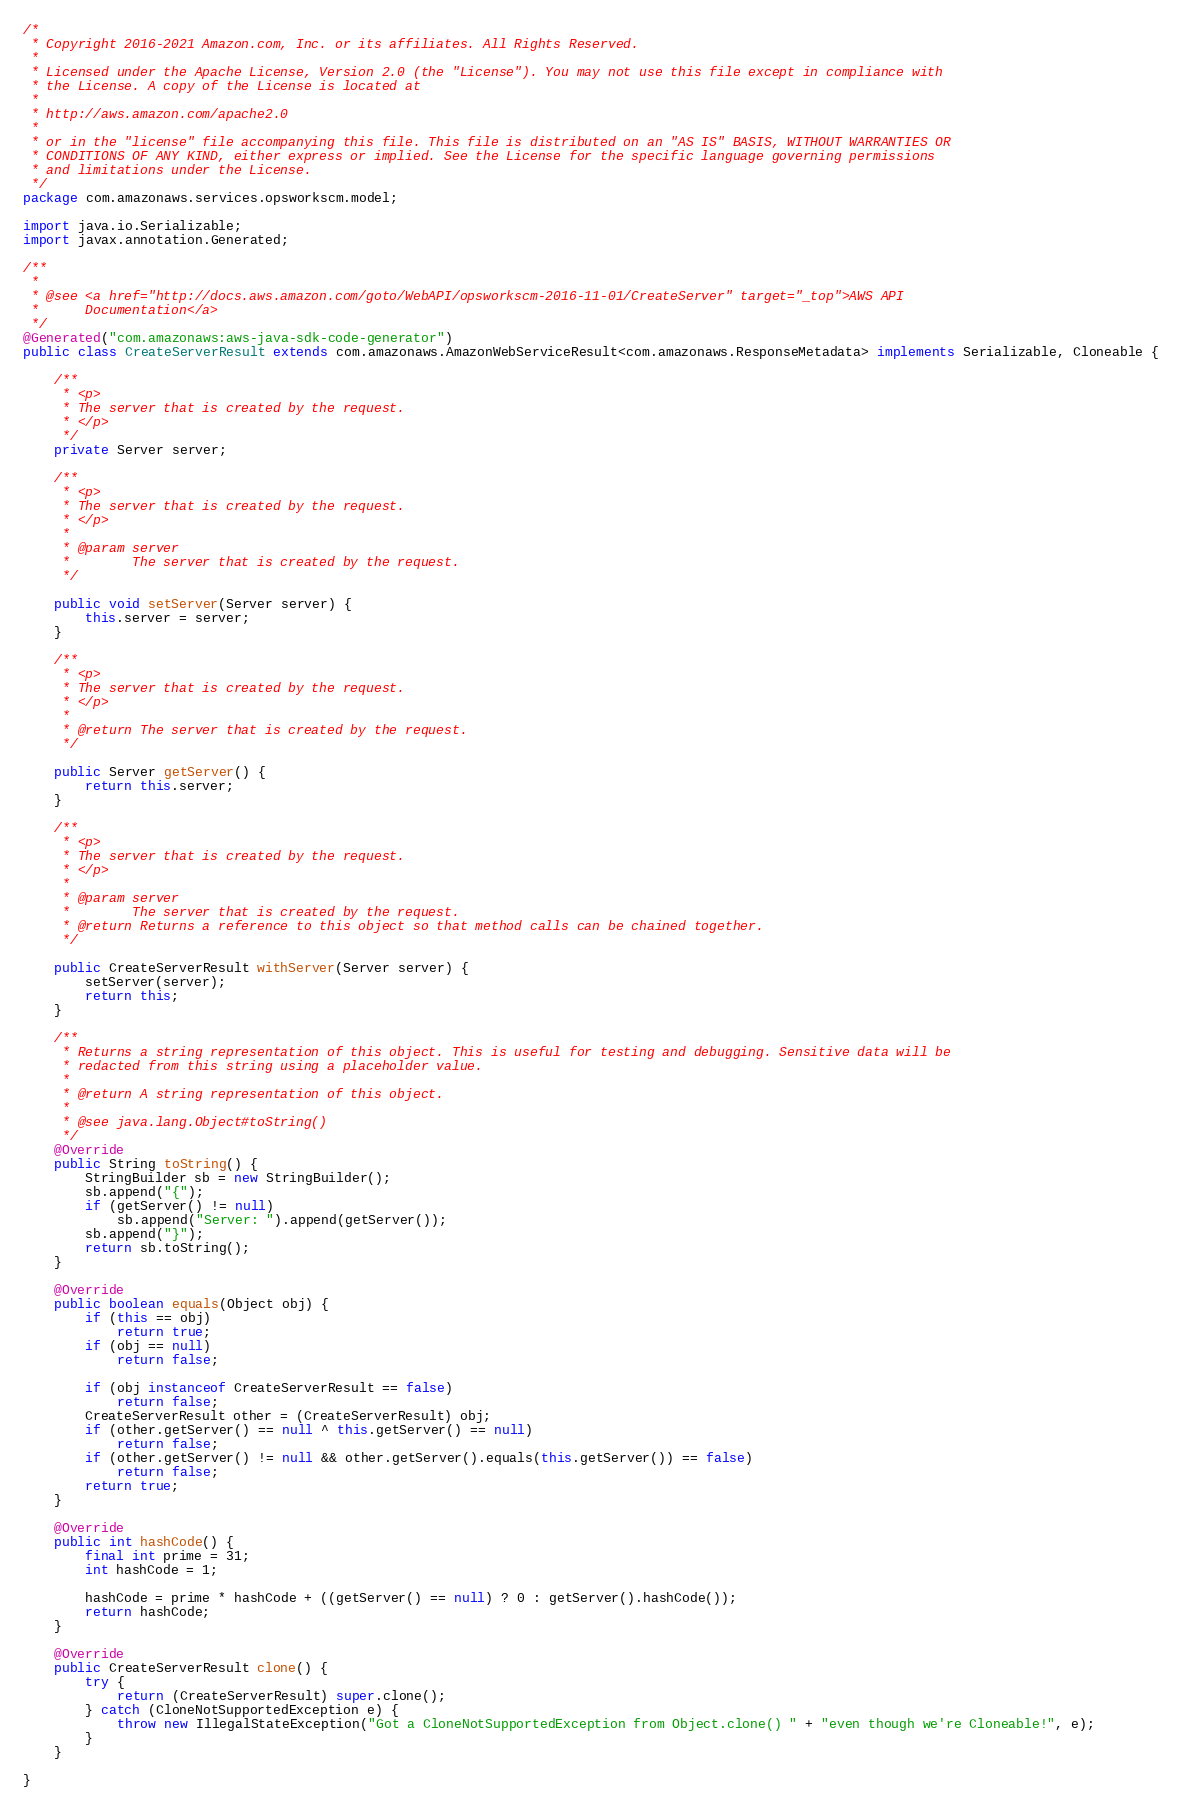<code> <loc_0><loc_0><loc_500><loc_500><_Java_>/*
 * Copyright 2016-2021 Amazon.com, Inc. or its affiliates. All Rights Reserved.
 * 
 * Licensed under the Apache License, Version 2.0 (the "License"). You may not use this file except in compliance with
 * the License. A copy of the License is located at
 * 
 * http://aws.amazon.com/apache2.0
 * 
 * or in the "license" file accompanying this file. This file is distributed on an "AS IS" BASIS, WITHOUT WARRANTIES OR
 * CONDITIONS OF ANY KIND, either express or implied. See the License for the specific language governing permissions
 * and limitations under the License.
 */
package com.amazonaws.services.opsworkscm.model;

import java.io.Serializable;
import javax.annotation.Generated;

/**
 * 
 * @see <a href="http://docs.aws.amazon.com/goto/WebAPI/opsworkscm-2016-11-01/CreateServer" target="_top">AWS API
 *      Documentation</a>
 */
@Generated("com.amazonaws:aws-java-sdk-code-generator")
public class CreateServerResult extends com.amazonaws.AmazonWebServiceResult<com.amazonaws.ResponseMetadata> implements Serializable, Cloneable {

    /**
     * <p>
     * The server that is created by the request.
     * </p>
     */
    private Server server;

    /**
     * <p>
     * The server that is created by the request.
     * </p>
     * 
     * @param server
     *        The server that is created by the request.
     */

    public void setServer(Server server) {
        this.server = server;
    }

    /**
     * <p>
     * The server that is created by the request.
     * </p>
     * 
     * @return The server that is created by the request.
     */

    public Server getServer() {
        return this.server;
    }

    /**
     * <p>
     * The server that is created by the request.
     * </p>
     * 
     * @param server
     *        The server that is created by the request.
     * @return Returns a reference to this object so that method calls can be chained together.
     */

    public CreateServerResult withServer(Server server) {
        setServer(server);
        return this;
    }

    /**
     * Returns a string representation of this object. This is useful for testing and debugging. Sensitive data will be
     * redacted from this string using a placeholder value.
     *
     * @return A string representation of this object.
     *
     * @see java.lang.Object#toString()
     */
    @Override
    public String toString() {
        StringBuilder sb = new StringBuilder();
        sb.append("{");
        if (getServer() != null)
            sb.append("Server: ").append(getServer());
        sb.append("}");
        return sb.toString();
    }

    @Override
    public boolean equals(Object obj) {
        if (this == obj)
            return true;
        if (obj == null)
            return false;

        if (obj instanceof CreateServerResult == false)
            return false;
        CreateServerResult other = (CreateServerResult) obj;
        if (other.getServer() == null ^ this.getServer() == null)
            return false;
        if (other.getServer() != null && other.getServer().equals(this.getServer()) == false)
            return false;
        return true;
    }

    @Override
    public int hashCode() {
        final int prime = 31;
        int hashCode = 1;

        hashCode = prime * hashCode + ((getServer() == null) ? 0 : getServer().hashCode());
        return hashCode;
    }

    @Override
    public CreateServerResult clone() {
        try {
            return (CreateServerResult) super.clone();
        } catch (CloneNotSupportedException e) {
            throw new IllegalStateException("Got a CloneNotSupportedException from Object.clone() " + "even though we're Cloneable!", e);
        }
    }

}
</code> 